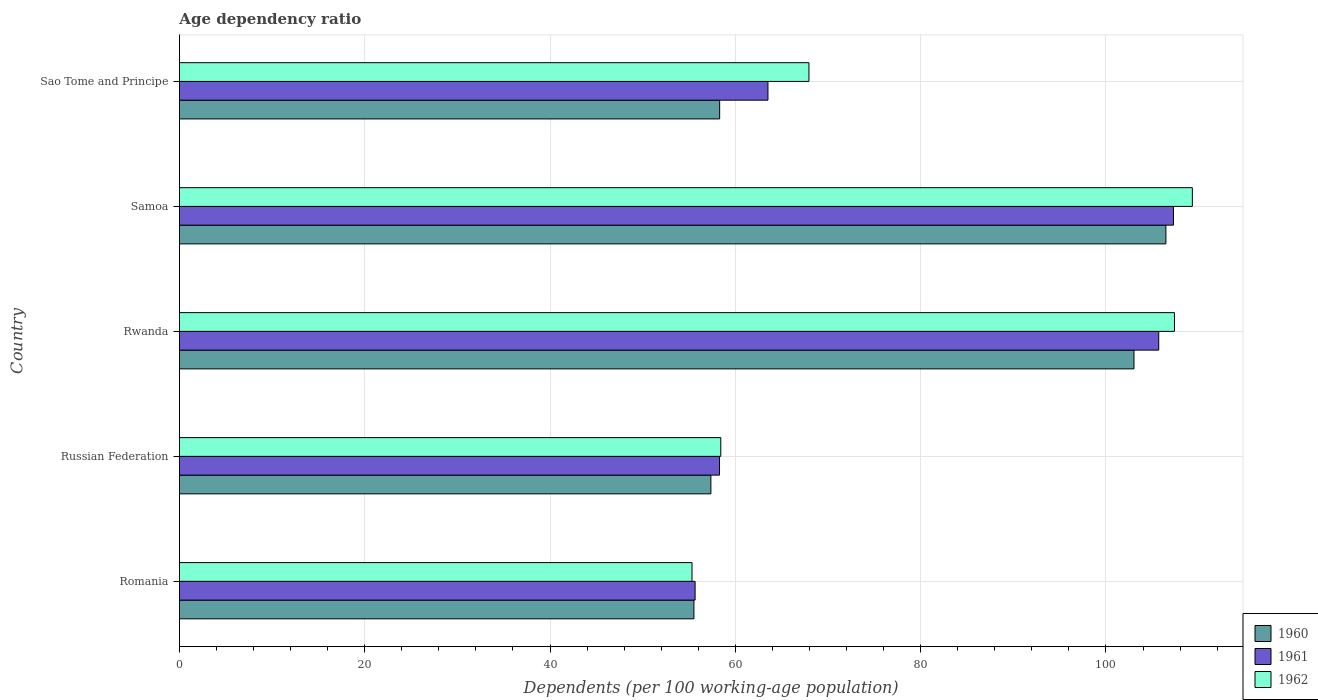How many different coloured bars are there?
Keep it short and to the point. 3. How many bars are there on the 2nd tick from the top?
Make the answer very short. 3. How many bars are there on the 5th tick from the bottom?
Your answer should be compact. 3. What is the label of the 5th group of bars from the top?
Offer a very short reply. Romania. What is the age dependency ratio in in 1961 in Sao Tome and Principe?
Ensure brevity in your answer.  63.52. Across all countries, what is the maximum age dependency ratio in in 1962?
Offer a terse response. 109.32. Across all countries, what is the minimum age dependency ratio in in 1961?
Your response must be concise. 55.66. In which country was the age dependency ratio in in 1962 maximum?
Make the answer very short. Samoa. In which country was the age dependency ratio in in 1962 minimum?
Provide a short and direct response. Romania. What is the total age dependency ratio in in 1961 in the graph?
Keep it short and to the point. 390.44. What is the difference between the age dependency ratio in in 1960 in Rwanda and that in Samoa?
Provide a succinct answer. -3.44. What is the difference between the age dependency ratio in in 1961 in Romania and the age dependency ratio in in 1960 in Samoa?
Your response must be concise. -50.81. What is the average age dependency ratio in in 1960 per country?
Provide a short and direct response. 76.14. What is the difference between the age dependency ratio in in 1961 and age dependency ratio in in 1962 in Romania?
Offer a very short reply. 0.34. What is the ratio of the age dependency ratio in in 1962 in Romania to that in Russian Federation?
Offer a very short reply. 0.95. Is the difference between the age dependency ratio in in 1961 in Romania and Samoa greater than the difference between the age dependency ratio in in 1962 in Romania and Samoa?
Keep it short and to the point. Yes. What is the difference between the highest and the second highest age dependency ratio in in 1960?
Offer a very short reply. 3.44. What is the difference between the highest and the lowest age dependency ratio in in 1960?
Ensure brevity in your answer.  50.94. What does the 2nd bar from the top in Samoa represents?
Make the answer very short. 1961. Is it the case that in every country, the sum of the age dependency ratio in in 1962 and age dependency ratio in in 1961 is greater than the age dependency ratio in in 1960?
Keep it short and to the point. Yes. How many bars are there?
Provide a short and direct response. 15. How many countries are there in the graph?
Provide a succinct answer. 5. Does the graph contain grids?
Provide a succinct answer. Yes. How many legend labels are there?
Give a very brief answer. 3. What is the title of the graph?
Give a very brief answer. Age dependency ratio. Does "1962" appear as one of the legend labels in the graph?
Provide a short and direct response. Yes. What is the label or title of the X-axis?
Make the answer very short. Dependents (per 100 working-age population). What is the Dependents (per 100 working-age population) in 1960 in Romania?
Your answer should be compact. 55.53. What is the Dependents (per 100 working-age population) in 1961 in Romania?
Your response must be concise. 55.66. What is the Dependents (per 100 working-age population) of 1962 in Romania?
Provide a succinct answer. 55.32. What is the Dependents (per 100 working-age population) of 1960 in Russian Federation?
Your answer should be compact. 57.36. What is the Dependents (per 100 working-age population) of 1961 in Russian Federation?
Your response must be concise. 58.29. What is the Dependents (per 100 working-age population) of 1962 in Russian Federation?
Give a very brief answer. 58.43. What is the Dependents (per 100 working-age population) of 1960 in Rwanda?
Your response must be concise. 103.02. What is the Dependents (per 100 working-age population) in 1961 in Rwanda?
Your response must be concise. 105.69. What is the Dependents (per 100 working-age population) of 1962 in Rwanda?
Ensure brevity in your answer.  107.39. What is the Dependents (per 100 working-age population) in 1960 in Samoa?
Keep it short and to the point. 106.47. What is the Dependents (per 100 working-age population) of 1961 in Samoa?
Offer a very short reply. 107.28. What is the Dependents (per 100 working-age population) in 1962 in Samoa?
Keep it short and to the point. 109.32. What is the Dependents (per 100 working-age population) of 1960 in Sao Tome and Principe?
Make the answer very short. 58.31. What is the Dependents (per 100 working-age population) in 1961 in Sao Tome and Principe?
Give a very brief answer. 63.52. What is the Dependents (per 100 working-age population) in 1962 in Sao Tome and Principe?
Offer a very short reply. 67.94. Across all countries, what is the maximum Dependents (per 100 working-age population) of 1960?
Offer a very short reply. 106.47. Across all countries, what is the maximum Dependents (per 100 working-age population) in 1961?
Your answer should be compact. 107.28. Across all countries, what is the maximum Dependents (per 100 working-age population) of 1962?
Your answer should be very brief. 109.32. Across all countries, what is the minimum Dependents (per 100 working-age population) in 1960?
Provide a short and direct response. 55.53. Across all countries, what is the minimum Dependents (per 100 working-age population) of 1961?
Your answer should be very brief. 55.66. Across all countries, what is the minimum Dependents (per 100 working-age population) of 1962?
Offer a very short reply. 55.32. What is the total Dependents (per 100 working-age population) in 1960 in the graph?
Offer a very short reply. 380.68. What is the total Dependents (per 100 working-age population) of 1961 in the graph?
Provide a short and direct response. 390.44. What is the total Dependents (per 100 working-age population) in 1962 in the graph?
Keep it short and to the point. 398.4. What is the difference between the Dependents (per 100 working-age population) of 1960 in Romania and that in Russian Federation?
Your response must be concise. -1.83. What is the difference between the Dependents (per 100 working-age population) of 1961 in Romania and that in Russian Federation?
Your answer should be very brief. -2.63. What is the difference between the Dependents (per 100 working-age population) in 1962 in Romania and that in Russian Federation?
Your answer should be compact. -3.11. What is the difference between the Dependents (per 100 working-age population) of 1960 in Romania and that in Rwanda?
Your answer should be compact. -47.49. What is the difference between the Dependents (per 100 working-age population) in 1961 in Romania and that in Rwanda?
Your response must be concise. -50.04. What is the difference between the Dependents (per 100 working-age population) in 1962 in Romania and that in Rwanda?
Ensure brevity in your answer.  -52.07. What is the difference between the Dependents (per 100 working-age population) of 1960 in Romania and that in Samoa?
Provide a succinct answer. -50.94. What is the difference between the Dependents (per 100 working-age population) of 1961 in Romania and that in Samoa?
Keep it short and to the point. -51.63. What is the difference between the Dependents (per 100 working-age population) in 1962 in Romania and that in Samoa?
Your answer should be compact. -54. What is the difference between the Dependents (per 100 working-age population) in 1960 in Romania and that in Sao Tome and Principe?
Provide a short and direct response. -2.78. What is the difference between the Dependents (per 100 working-age population) in 1961 in Romania and that in Sao Tome and Principe?
Give a very brief answer. -7.86. What is the difference between the Dependents (per 100 working-age population) in 1962 in Romania and that in Sao Tome and Principe?
Ensure brevity in your answer.  -12.62. What is the difference between the Dependents (per 100 working-age population) in 1960 in Russian Federation and that in Rwanda?
Your response must be concise. -45.66. What is the difference between the Dependents (per 100 working-age population) of 1961 in Russian Federation and that in Rwanda?
Offer a very short reply. -47.4. What is the difference between the Dependents (per 100 working-age population) of 1962 in Russian Federation and that in Rwanda?
Your response must be concise. -48.96. What is the difference between the Dependents (per 100 working-age population) of 1960 in Russian Federation and that in Samoa?
Ensure brevity in your answer.  -49.11. What is the difference between the Dependents (per 100 working-age population) in 1961 in Russian Federation and that in Samoa?
Offer a terse response. -48.99. What is the difference between the Dependents (per 100 working-age population) in 1962 in Russian Federation and that in Samoa?
Your answer should be very brief. -50.89. What is the difference between the Dependents (per 100 working-age population) in 1960 in Russian Federation and that in Sao Tome and Principe?
Your answer should be compact. -0.95. What is the difference between the Dependents (per 100 working-age population) in 1961 in Russian Federation and that in Sao Tome and Principe?
Provide a short and direct response. -5.23. What is the difference between the Dependents (per 100 working-age population) of 1962 in Russian Federation and that in Sao Tome and Principe?
Offer a very short reply. -9.51. What is the difference between the Dependents (per 100 working-age population) in 1960 in Rwanda and that in Samoa?
Offer a terse response. -3.44. What is the difference between the Dependents (per 100 working-age population) of 1961 in Rwanda and that in Samoa?
Provide a succinct answer. -1.59. What is the difference between the Dependents (per 100 working-age population) in 1962 in Rwanda and that in Samoa?
Give a very brief answer. -1.93. What is the difference between the Dependents (per 100 working-age population) of 1960 in Rwanda and that in Sao Tome and Principe?
Your answer should be compact. 44.72. What is the difference between the Dependents (per 100 working-age population) in 1961 in Rwanda and that in Sao Tome and Principe?
Your answer should be very brief. 42.17. What is the difference between the Dependents (per 100 working-age population) in 1962 in Rwanda and that in Sao Tome and Principe?
Make the answer very short. 39.45. What is the difference between the Dependents (per 100 working-age population) of 1960 in Samoa and that in Sao Tome and Principe?
Provide a succinct answer. 48.16. What is the difference between the Dependents (per 100 working-age population) of 1961 in Samoa and that in Sao Tome and Principe?
Provide a short and direct response. 43.76. What is the difference between the Dependents (per 100 working-age population) in 1962 in Samoa and that in Sao Tome and Principe?
Give a very brief answer. 41.38. What is the difference between the Dependents (per 100 working-age population) in 1960 in Romania and the Dependents (per 100 working-age population) in 1961 in Russian Federation?
Give a very brief answer. -2.76. What is the difference between the Dependents (per 100 working-age population) of 1960 in Romania and the Dependents (per 100 working-age population) of 1962 in Russian Federation?
Keep it short and to the point. -2.9. What is the difference between the Dependents (per 100 working-age population) in 1961 in Romania and the Dependents (per 100 working-age population) in 1962 in Russian Federation?
Give a very brief answer. -2.77. What is the difference between the Dependents (per 100 working-age population) of 1960 in Romania and the Dependents (per 100 working-age population) of 1961 in Rwanda?
Offer a terse response. -50.17. What is the difference between the Dependents (per 100 working-age population) in 1960 in Romania and the Dependents (per 100 working-age population) in 1962 in Rwanda?
Your answer should be very brief. -51.86. What is the difference between the Dependents (per 100 working-age population) of 1961 in Romania and the Dependents (per 100 working-age population) of 1962 in Rwanda?
Give a very brief answer. -51.73. What is the difference between the Dependents (per 100 working-age population) of 1960 in Romania and the Dependents (per 100 working-age population) of 1961 in Samoa?
Give a very brief answer. -51.75. What is the difference between the Dependents (per 100 working-age population) of 1960 in Romania and the Dependents (per 100 working-age population) of 1962 in Samoa?
Offer a very short reply. -53.79. What is the difference between the Dependents (per 100 working-age population) in 1961 in Romania and the Dependents (per 100 working-age population) in 1962 in Samoa?
Offer a very short reply. -53.66. What is the difference between the Dependents (per 100 working-age population) of 1960 in Romania and the Dependents (per 100 working-age population) of 1961 in Sao Tome and Principe?
Your answer should be compact. -7.99. What is the difference between the Dependents (per 100 working-age population) of 1960 in Romania and the Dependents (per 100 working-age population) of 1962 in Sao Tome and Principe?
Ensure brevity in your answer.  -12.41. What is the difference between the Dependents (per 100 working-age population) of 1961 in Romania and the Dependents (per 100 working-age population) of 1962 in Sao Tome and Principe?
Offer a terse response. -12.28. What is the difference between the Dependents (per 100 working-age population) in 1960 in Russian Federation and the Dependents (per 100 working-age population) in 1961 in Rwanda?
Ensure brevity in your answer.  -48.33. What is the difference between the Dependents (per 100 working-age population) of 1960 in Russian Federation and the Dependents (per 100 working-age population) of 1962 in Rwanda?
Offer a terse response. -50.03. What is the difference between the Dependents (per 100 working-age population) in 1961 in Russian Federation and the Dependents (per 100 working-age population) in 1962 in Rwanda?
Keep it short and to the point. -49.1. What is the difference between the Dependents (per 100 working-age population) in 1960 in Russian Federation and the Dependents (per 100 working-age population) in 1961 in Samoa?
Your answer should be very brief. -49.92. What is the difference between the Dependents (per 100 working-age population) in 1960 in Russian Federation and the Dependents (per 100 working-age population) in 1962 in Samoa?
Make the answer very short. -51.96. What is the difference between the Dependents (per 100 working-age population) in 1961 in Russian Federation and the Dependents (per 100 working-age population) in 1962 in Samoa?
Make the answer very short. -51.03. What is the difference between the Dependents (per 100 working-age population) in 1960 in Russian Federation and the Dependents (per 100 working-age population) in 1961 in Sao Tome and Principe?
Ensure brevity in your answer.  -6.16. What is the difference between the Dependents (per 100 working-age population) of 1960 in Russian Federation and the Dependents (per 100 working-age population) of 1962 in Sao Tome and Principe?
Keep it short and to the point. -10.58. What is the difference between the Dependents (per 100 working-age population) in 1961 in Russian Federation and the Dependents (per 100 working-age population) in 1962 in Sao Tome and Principe?
Make the answer very short. -9.65. What is the difference between the Dependents (per 100 working-age population) in 1960 in Rwanda and the Dependents (per 100 working-age population) in 1961 in Samoa?
Provide a succinct answer. -4.26. What is the difference between the Dependents (per 100 working-age population) in 1960 in Rwanda and the Dependents (per 100 working-age population) in 1962 in Samoa?
Provide a succinct answer. -6.3. What is the difference between the Dependents (per 100 working-age population) in 1961 in Rwanda and the Dependents (per 100 working-age population) in 1962 in Samoa?
Offer a terse response. -3.63. What is the difference between the Dependents (per 100 working-age population) in 1960 in Rwanda and the Dependents (per 100 working-age population) in 1961 in Sao Tome and Principe?
Your answer should be very brief. 39.5. What is the difference between the Dependents (per 100 working-age population) of 1960 in Rwanda and the Dependents (per 100 working-age population) of 1962 in Sao Tome and Principe?
Offer a terse response. 35.08. What is the difference between the Dependents (per 100 working-age population) of 1961 in Rwanda and the Dependents (per 100 working-age population) of 1962 in Sao Tome and Principe?
Your answer should be very brief. 37.75. What is the difference between the Dependents (per 100 working-age population) of 1960 in Samoa and the Dependents (per 100 working-age population) of 1961 in Sao Tome and Principe?
Give a very brief answer. 42.95. What is the difference between the Dependents (per 100 working-age population) in 1960 in Samoa and the Dependents (per 100 working-age population) in 1962 in Sao Tome and Principe?
Make the answer very short. 38.53. What is the difference between the Dependents (per 100 working-age population) in 1961 in Samoa and the Dependents (per 100 working-age population) in 1962 in Sao Tome and Principe?
Your response must be concise. 39.34. What is the average Dependents (per 100 working-age population) of 1960 per country?
Provide a succinct answer. 76.14. What is the average Dependents (per 100 working-age population) of 1961 per country?
Offer a terse response. 78.09. What is the average Dependents (per 100 working-age population) in 1962 per country?
Your answer should be very brief. 79.68. What is the difference between the Dependents (per 100 working-age population) in 1960 and Dependents (per 100 working-age population) in 1961 in Romania?
Your response must be concise. -0.13. What is the difference between the Dependents (per 100 working-age population) of 1960 and Dependents (per 100 working-age population) of 1962 in Romania?
Offer a very short reply. 0.21. What is the difference between the Dependents (per 100 working-age population) of 1961 and Dependents (per 100 working-age population) of 1962 in Romania?
Your answer should be compact. 0.34. What is the difference between the Dependents (per 100 working-age population) of 1960 and Dependents (per 100 working-age population) of 1961 in Russian Federation?
Offer a terse response. -0.93. What is the difference between the Dependents (per 100 working-age population) in 1960 and Dependents (per 100 working-age population) in 1962 in Russian Federation?
Offer a terse response. -1.07. What is the difference between the Dependents (per 100 working-age population) in 1961 and Dependents (per 100 working-age population) in 1962 in Russian Federation?
Your answer should be compact. -0.14. What is the difference between the Dependents (per 100 working-age population) of 1960 and Dependents (per 100 working-age population) of 1961 in Rwanda?
Your response must be concise. -2.67. What is the difference between the Dependents (per 100 working-age population) of 1960 and Dependents (per 100 working-age population) of 1962 in Rwanda?
Ensure brevity in your answer.  -4.37. What is the difference between the Dependents (per 100 working-age population) in 1961 and Dependents (per 100 working-age population) in 1962 in Rwanda?
Your answer should be very brief. -1.7. What is the difference between the Dependents (per 100 working-age population) of 1960 and Dependents (per 100 working-age population) of 1961 in Samoa?
Offer a terse response. -0.82. What is the difference between the Dependents (per 100 working-age population) of 1960 and Dependents (per 100 working-age population) of 1962 in Samoa?
Offer a terse response. -2.85. What is the difference between the Dependents (per 100 working-age population) of 1961 and Dependents (per 100 working-age population) of 1962 in Samoa?
Ensure brevity in your answer.  -2.04. What is the difference between the Dependents (per 100 working-age population) in 1960 and Dependents (per 100 working-age population) in 1961 in Sao Tome and Principe?
Your response must be concise. -5.21. What is the difference between the Dependents (per 100 working-age population) of 1960 and Dependents (per 100 working-age population) of 1962 in Sao Tome and Principe?
Make the answer very short. -9.63. What is the difference between the Dependents (per 100 working-age population) of 1961 and Dependents (per 100 working-age population) of 1962 in Sao Tome and Principe?
Your answer should be compact. -4.42. What is the ratio of the Dependents (per 100 working-age population) of 1960 in Romania to that in Russian Federation?
Your answer should be very brief. 0.97. What is the ratio of the Dependents (per 100 working-age population) in 1961 in Romania to that in Russian Federation?
Give a very brief answer. 0.95. What is the ratio of the Dependents (per 100 working-age population) in 1962 in Romania to that in Russian Federation?
Your answer should be compact. 0.95. What is the ratio of the Dependents (per 100 working-age population) of 1960 in Romania to that in Rwanda?
Your answer should be very brief. 0.54. What is the ratio of the Dependents (per 100 working-age population) of 1961 in Romania to that in Rwanda?
Your answer should be compact. 0.53. What is the ratio of the Dependents (per 100 working-age population) in 1962 in Romania to that in Rwanda?
Your response must be concise. 0.52. What is the ratio of the Dependents (per 100 working-age population) in 1960 in Romania to that in Samoa?
Provide a succinct answer. 0.52. What is the ratio of the Dependents (per 100 working-age population) in 1961 in Romania to that in Samoa?
Make the answer very short. 0.52. What is the ratio of the Dependents (per 100 working-age population) in 1962 in Romania to that in Samoa?
Make the answer very short. 0.51. What is the ratio of the Dependents (per 100 working-age population) of 1960 in Romania to that in Sao Tome and Principe?
Offer a very short reply. 0.95. What is the ratio of the Dependents (per 100 working-age population) of 1961 in Romania to that in Sao Tome and Principe?
Ensure brevity in your answer.  0.88. What is the ratio of the Dependents (per 100 working-age population) in 1962 in Romania to that in Sao Tome and Principe?
Give a very brief answer. 0.81. What is the ratio of the Dependents (per 100 working-age population) of 1960 in Russian Federation to that in Rwanda?
Your response must be concise. 0.56. What is the ratio of the Dependents (per 100 working-age population) in 1961 in Russian Federation to that in Rwanda?
Your response must be concise. 0.55. What is the ratio of the Dependents (per 100 working-age population) in 1962 in Russian Federation to that in Rwanda?
Your answer should be compact. 0.54. What is the ratio of the Dependents (per 100 working-age population) in 1960 in Russian Federation to that in Samoa?
Keep it short and to the point. 0.54. What is the ratio of the Dependents (per 100 working-age population) in 1961 in Russian Federation to that in Samoa?
Ensure brevity in your answer.  0.54. What is the ratio of the Dependents (per 100 working-age population) of 1962 in Russian Federation to that in Samoa?
Your response must be concise. 0.53. What is the ratio of the Dependents (per 100 working-age population) of 1960 in Russian Federation to that in Sao Tome and Principe?
Keep it short and to the point. 0.98. What is the ratio of the Dependents (per 100 working-age population) in 1961 in Russian Federation to that in Sao Tome and Principe?
Keep it short and to the point. 0.92. What is the ratio of the Dependents (per 100 working-age population) in 1962 in Russian Federation to that in Sao Tome and Principe?
Ensure brevity in your answer.  0.86. What is the ratio of the Dependents (per 100 working-age population) of 1960 in Rwanda to that in Samoa?
Your response must be concise. 0.97. What is the ratio of the Dependents (per 100 working-age population) in 1961 in Rwanda to that in Samoa?
Give a very brief answer. 0.99. What is the ratio of the Dependents (per 100 working-age population) of 1962 in Rwanda to that in Samoa?
Offer a very short reply. 0.98. What is the ratio of the Dependents (per 100 working-age population) of 1960 in Rwanda to that in Sao Tome and Principe?
Offer a very short reply. 1.77. What is the ratio of the Dependents (per 100 working-age population) of 1961 in Rwanda to that in Sao Tome and Principe?
Your response must be concise. 1.66. What is the ratio of the Dependents (per 100 working-age population) of 1962 in Rwanda to that in Sao Tome and Principe?
Provide a succinct answer. 1.58. What is the ratio of the Dependents (per 100 working-age population) in 1960 in Samoa to that in Sao Tome and Principe?
Provide a succinct answer. 1.83. What is the ratio of the Dependents (per 100 working-age population) of 1961 in Samoa to that in Sao Tome and Principe?
Offer a terse response. 1.69. What is the ratio of the Dependents (per 100 working-age population) in 1962 in Samoa to that in Sao Tome and Principe?
Provide a succinct answer. 1.61. What is the difference between the highest and the second highest Dependents (per 100 working-age population) in 1960?
Give a very brief answer. 3.44. What is the difference between the highest and the second highest Dependents (per 100 working-age population) of 1961?
Offer a terse response. 1.59. What is the difference between the highest and the second highest Dependents (per 100 working-age population) of 1962?
Keep it short and to the point. 1.93. What is the difference between the highest and the lowest Dependents (per 100 working-age population) of 1960?
Make the answer very short. 50.94. What is the difference between the highest and the lowest Dependents (per 100 working-age population) of 1961?
Your answer should be very brief. 51.63. What is the difference between the highest and the lowest Dependents (per 100 working-age population) in 1962?
Provide a short and direct response. 54. 